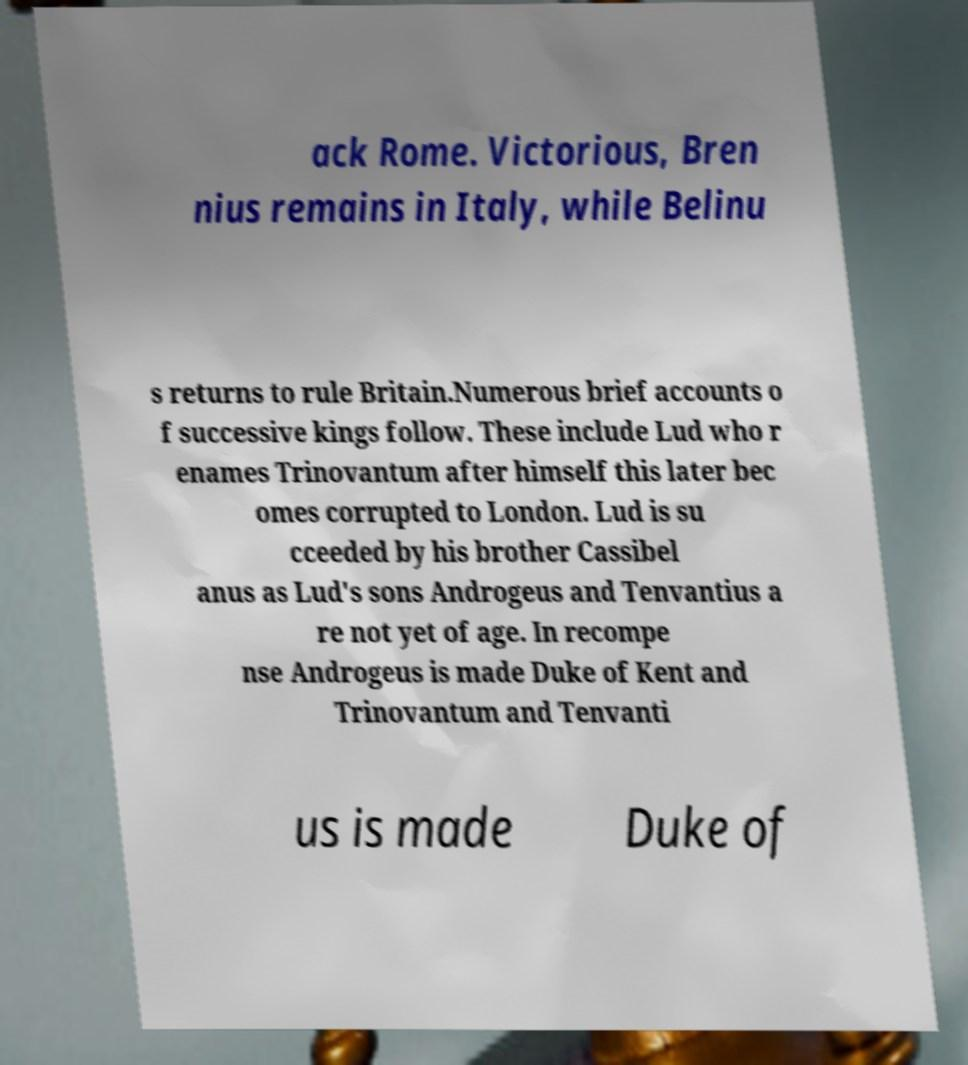There's text embedded in this image that I need extracted. Can you transcribe it verbatim? ack Rome. Victorious, Bren nius remains in Italy, while Belinu s returns to rule Britain.Numerous brief accounts o f successive kings follow. These include Lud who r enames Trinovantum after himself this later bec omes corrupted to London. Lud is su cceeded by his brother Cassibel anus as Lud's sons Androgeus and Tenvantius a re not yet of age. In recompe nse Androgeus is made Duke of Kent and Trinovantum and Tenvanti us is made Duke of 